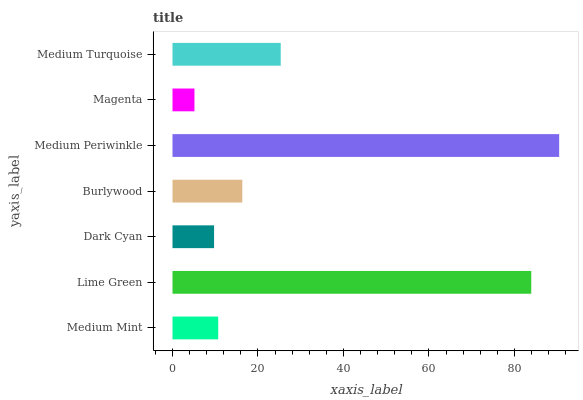Is Magenta the minimum?
Answer yes or no. Yes. Is Medium Periwinkle the maximum?
Answer yes or no. Yes. Is Lime Green the minimum?
Answer yes or no. No. Is Lime Green the maximum?
Answer yes or no. No. Is Lime Green greater than Medium Mint?
Answer yes or no. Yes. Is Medium Mint less than Lime Green?
Answer yes or no. Yes. Is Medium Mint greater than Lime Green?
Answer yes or no. No. Is Lime Green less than Medium Mint?
Answer yes or no. No. Is Burlywood the high median?
Answer yes or no. Yes. Is Burlywood the low median?
Answer yes or no. Yes. Is Medium Turquoise the high median?
Answer yes or no. No. Is Magenta the low median?
Answer yes or no. No. 